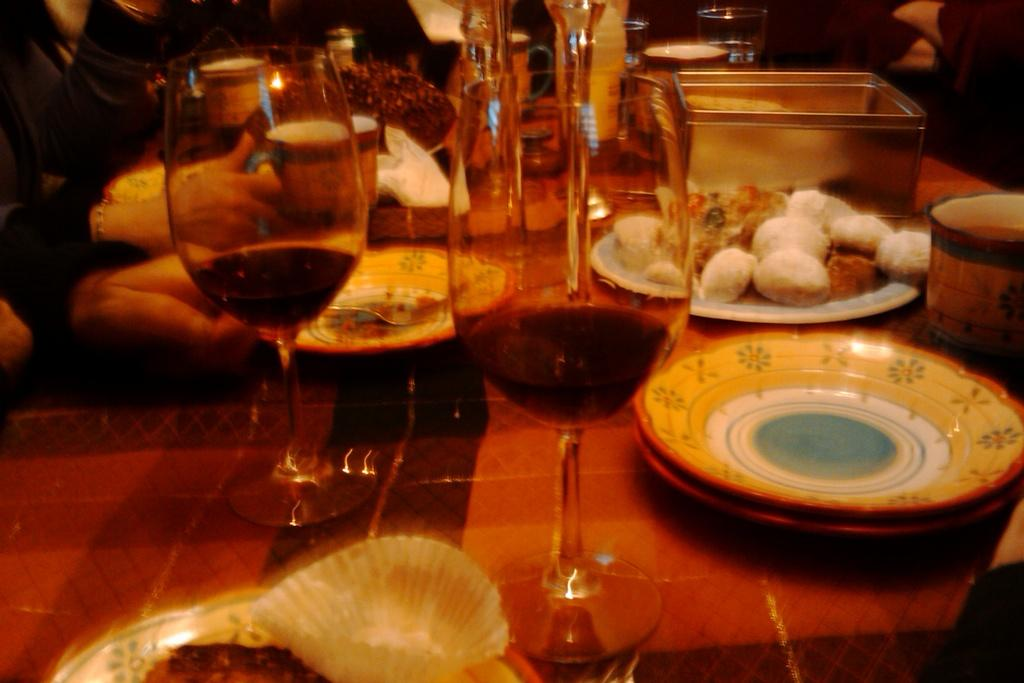What type of tableware can be seen on the table in the image? There are glasses, plates, and bowls on the table in the image. What type of food is present on the table? There is a cake and other food on the table. What is the primary purpose of the tableware on the table? The tableware is used for serving and consuming food. Who might be using the tableware and food on the table? There are people near the table, suggesting they might be using the tableware and food. What type of mint can be seen growing near the table in the image? There is no mint visible in the image; the focus is on the tableware, food, and people near the table. 